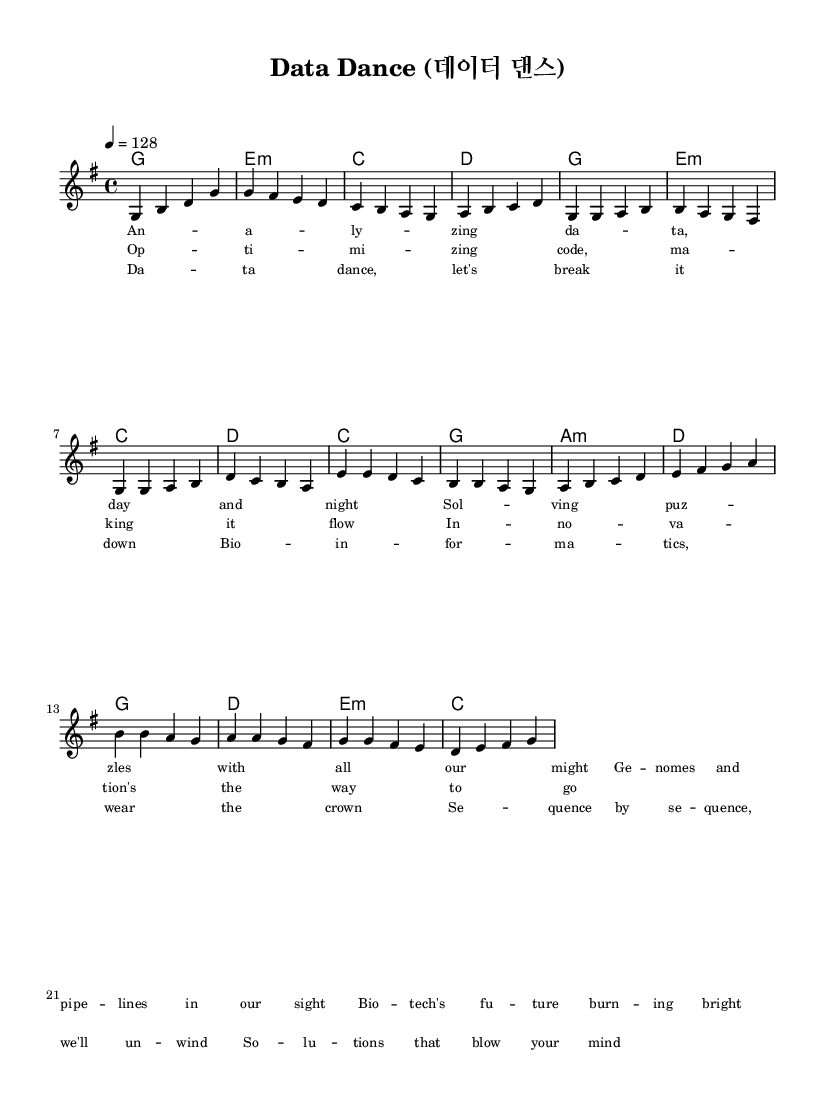What is the key signature of this music? The key signature shows one sharp, indicating it is in G major. The notes played in this piece align with the notes of the G major scale.
Answer: G major What is the time signature of this music? The time signature is indicated in the music sheet as 4/4, which means there are four beats in each measure and the quarter note receives one beat.
Answer: 4/4 What is the tempo marking of this piece? The tempo marking of the music indicates a speed of 128 beats per minute, which is typical for upbeat K-pop songs.
Answer: 128 How many measures are in the chorus section? In the sheet music, the chorus section consists of four measures, as seen in the repeating pattern of notes.
Answer: 4 measures What theme is primarily highlighted in the lyrics? The lyrics focus on themes of data analysis and problem-solving, particularly in the context of bioinformatics.
Answer: Data analysis How does the pre-chorus transition musically to the chorus? The pre-chorus transitions to the chorus by resolving from a minor chord sequence to a more uplifting major chord, creating a sense of climax and readiness for the chorus.
Answer: Major chord shift What K-pop characteristic is reflected in the song's structure? The song features a clear structure of verse, pre-chorus, and chorus, which is a defining characteristic of K-pop music, allowing for dynamic transitions.
Answer: Clear structure 